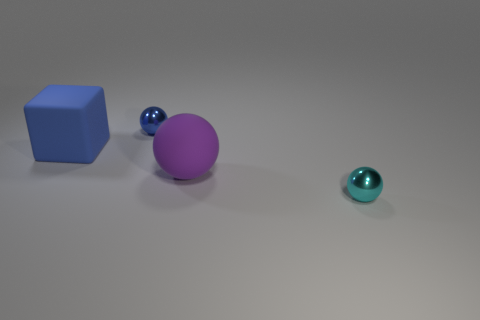Subtract all matte balls. How many balls are left? 2 Add 2 big blue rubber objects. How many objects exist? 6 Subtract all cyan balls. How many balls are left? 2 Subtract all cubes. How many objects are left? 3 Subtract 2 balls. How many balls are left? 1 Subtract all big green shiny balls. Subtract all small cyan objects. How many objects are left? 3 Add 4 large spheres. How many large spheres are left? 5 Add 1 large blue objects. How many large blue objects exist? 2 Subtract 0 cyan cylinders. How many objects are left? 4 Subtract all brown cubes. Subtract all red balls. How many cubes are left? 1 